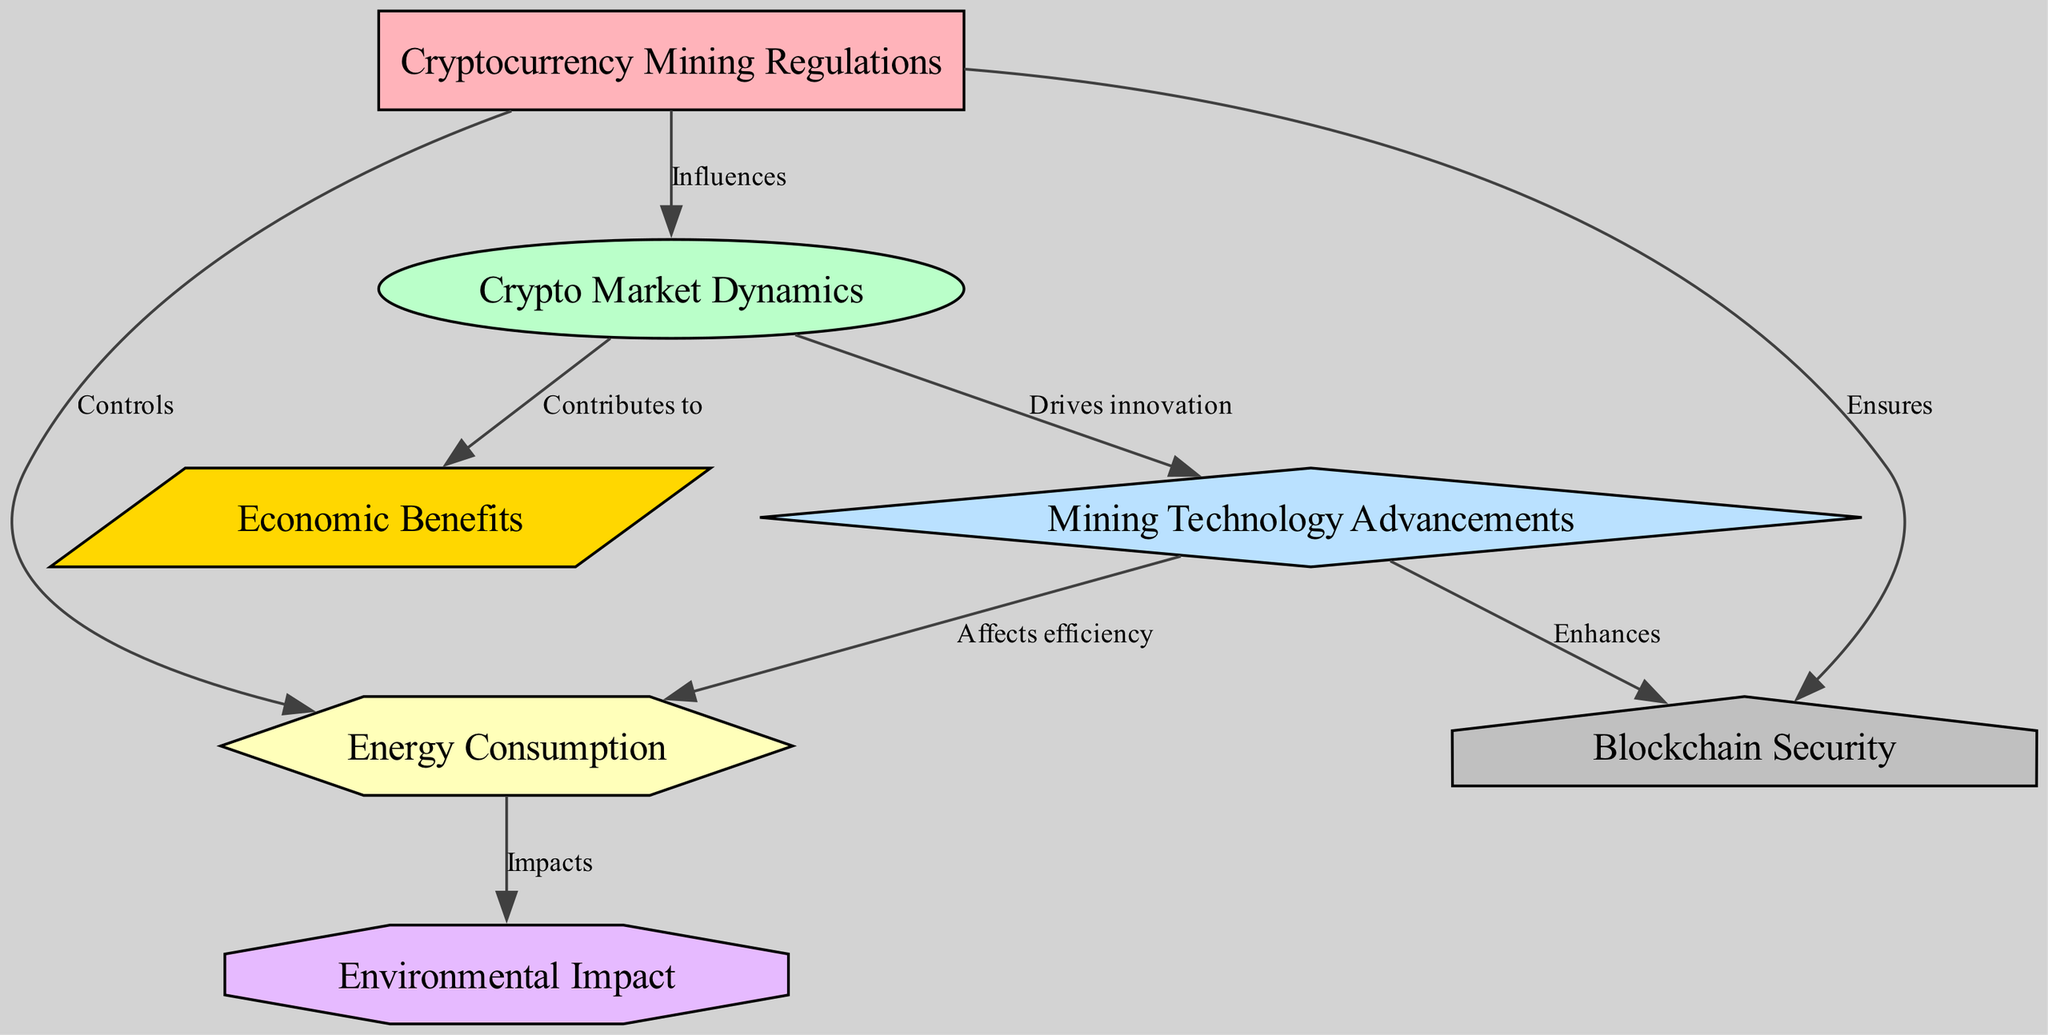What are the main nodes in the diagram? The diagram consists of the following seven nodes: Cryptocurrency Mining Regulations, Crypto Market Dynamics, Mining Technology Advancements, Energy Consumption, Environmental Impact, Economic Benefits, and Blockchain Security.
Answer: Cryptocurrency Mining Regulations, Crypto Market Dynamics, Mining Technology Advancements, Energy Consumption, Environmental Impact, Economic Benefits, Blockchain Security How many edges connect the regulations to other nodes? The edges from the Cryptocurrency Mining Regulations node connect to three other nodes: Crypto Market Dynamics, Energy Consumption, and Blockchain Security, resulting in a total of three edges.
Answer: 3 Which node is affected by mining technology advancements? Mining Technology Advancements affects Energy Consumption. The arrow from Mining Technology Advancements points to Energy Consumption, indicating an influence in terms of efficiency.
Answer: Energy Consumption What type of relationship exists between regulations and energy? The relationship indicates that Cryptocurrency Mining Regulations controls Energy Consumption, meaning the regulations have a governing influence over energy use in mining.
Answer: Controls What contributes to the economy according to the diagram? The Crypto Market Dynamics node contributes to the Economic Benefits. This is represented by a directed edge going from the market node to the economy node.
Answer: Economic Benefits How does technology advancement relate to blockchain security? Mining Technology Advancements enhances Blockchain Security, which illustrates that improvements in mining technology provide a stronger foundation for blockchain security measures.
Answer: Enhances What impact does energy consumption have on the environment? Energy Consumption has an impact on Environmental Impact, showing that the amount of energy consumed in mining activities affects the environmental consequences of those activities.
Answer: Impacts How many nodes are related to energy consumption directly? Energy Consumption is related to two nodes directly; it is influenced by Mining Technology Advancements and impacts Environmental Impact.
Answer: 2 What role do cryptocurrency mining regulations play in market dynamics? Cryptocurrency Mining Regulations influences Crypto Market Dynamics, signifying that the framework and restrictions set by regulations can shape the behavior and trends in the cryptocurrency market.
Answer: Influences 